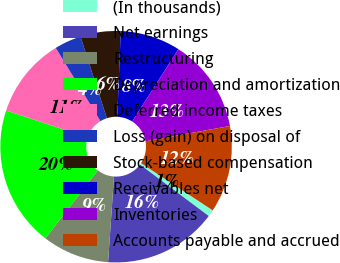Convert chart. <chart><loc_0><loc_0><loc_500><loc_500><pie_chart><fcel>(In thousands)<fcel>Net earnings<fcel>Restructuring<fcel>Depreciation and amortization<fcel>Deferred income taxes<fcel>Loss (gain) on disposal of<fcel>Stock-based compensation<fcel>Receivables net<fcel>Inventories<fcel>Accounts payable and accrued<nl><fcel>0.95%<fcel>15.88%<fcel>9.35%<fcel>19.61%<fcel>11.21%<fcel>3.75%<fcel>5.62%<fcel>8.41%<fcel>13.08%<fcel>12.14%<nl></chart> 